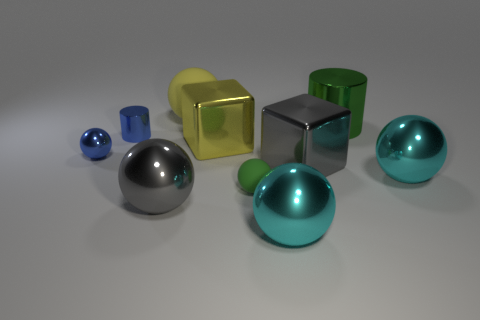Subtract all large cyan metal spheres. How many spheres are left? 4 Subtract all yellow balls. How many balls are left? 5 Subtract all purple cylinders. How many cyan balls are left? 2 Subtract all cylinders. How many objects are left? 8 Subtract 1 blocks. How many blocks are left? 1 Subtract 0 brown balls. How many objects are left? 10 Subtract all yellow blocks. Subtract all blue spheres. How many blocks are left? 1 Subtract all tiny blue shiny spheres. Subtract all tiny cubes. How many objects are left? 9 Add 2 yellow things. How many yellow things are left? 4 Add 2 cyan metal things. How many cyan metal things exist? 4 